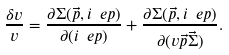Convert formula to latex. <formula><loc_0><loc_0><loc_500><loc_500>\frac { \delta { v } } { v } = \frac { \partial \Sigma ( \vec { p } , i \ e p ) } { \partial ( i \ e p ) } + \frac { \partial \Sigma ( \vec { p } , i \ e p ) } { \partial ( v \vec { p } \vec { \Sigma } ) } .</formula> 